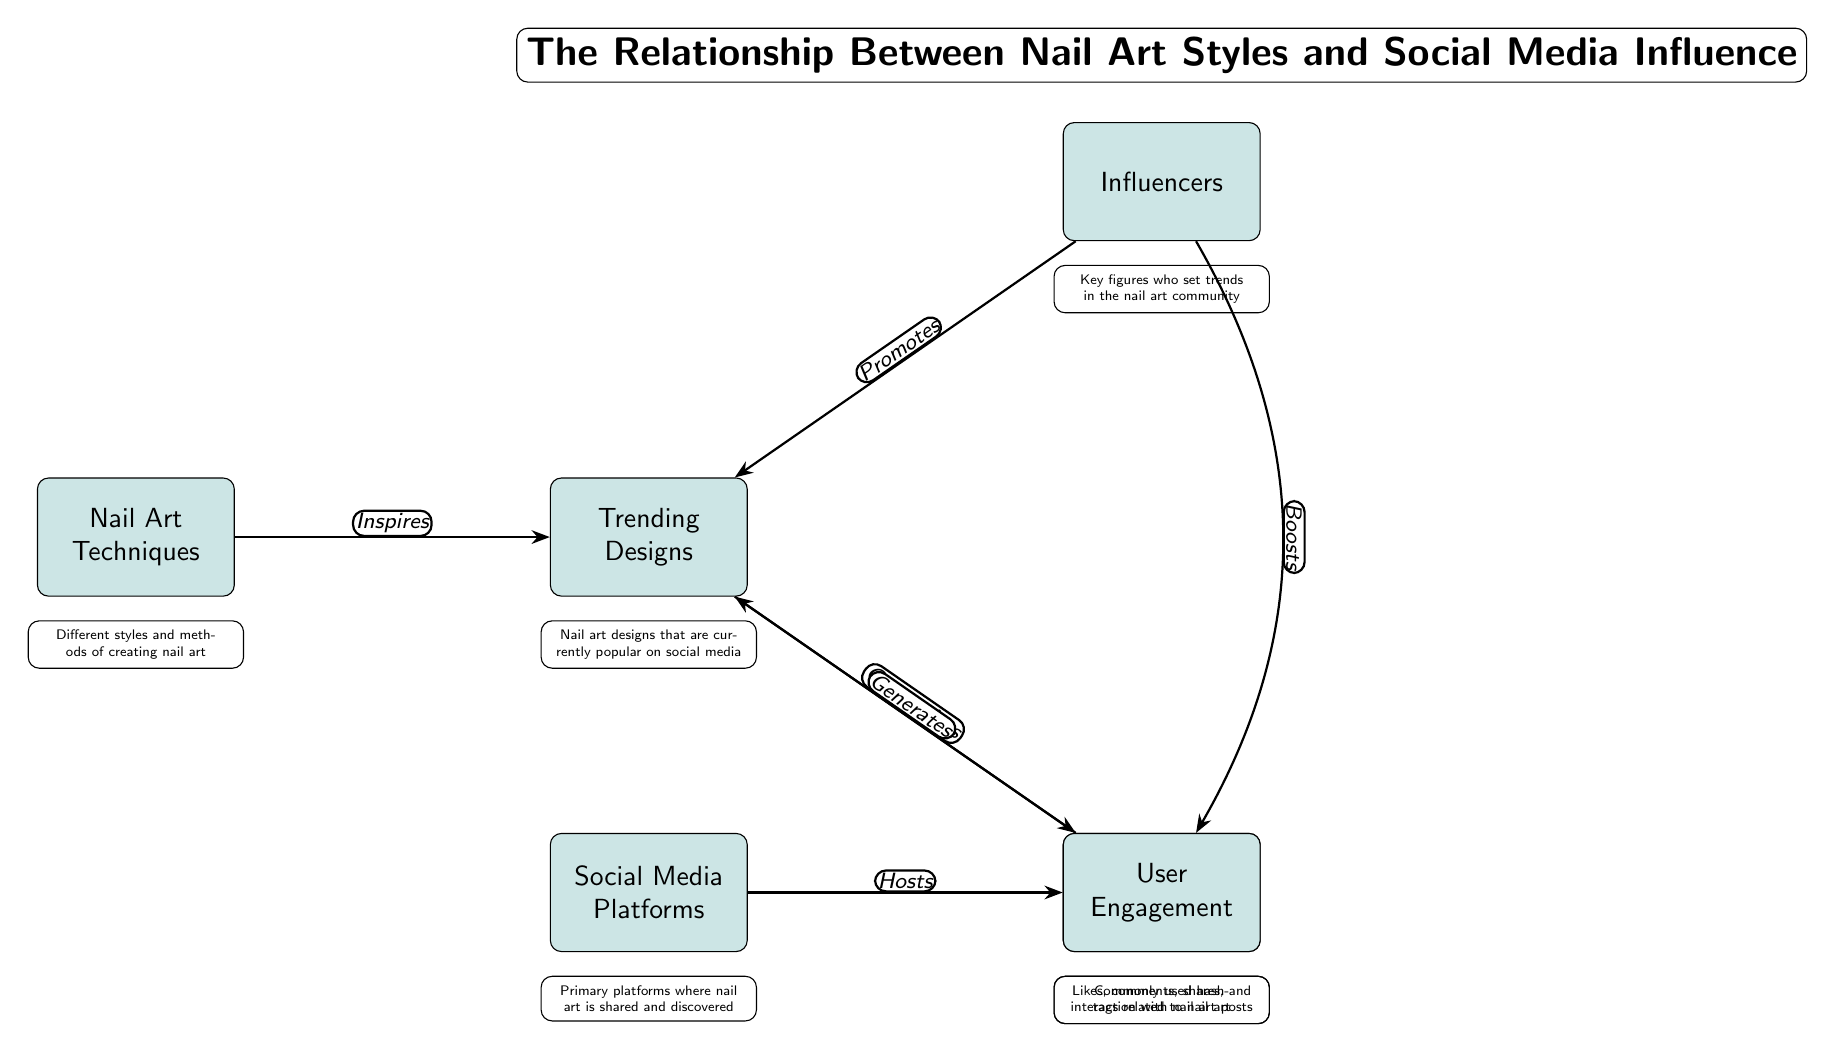What are the nodes represented in the diagram? The diagram consists of six main nodes: Nail Art Techniques, Trending Designs, Social Media Platforms, Popular Hashtags, Influencers, and User Engagement.
Answer: Six What type of relationship does "Social Media Platforms" have with "Popular Hashtags"? The relationship is labeled as "Hosts," indicating that social media platforms are the venues where popular hashtags are found.
Answer: Hosts How many edges are connecting different nodes in the diagram? There are a total of six edges connecting the nodes, which indicate the various relationships between the elements.
Answer: Six Which node directly influences the "Trending Designs"? The "Influencers" node directly influences "Trending Designs," suggesting that influential figures promote particular nail art designs.
Answer: Influencers What does "User Engagement" result from? User engagement results from the trending designs, indicating that they generate likes, comments, shares, etc. This shows the impact of designs on interaction levels.
Answer: Trending Designs How does "Nail Art Techniques" affect "Trending Designs"? Nail Art Techniques inspires Trending Designs, suggesting that the various techniques available lead to the development of new and popular design ideas.
Answer: Inspires Which node is categorized by "Popular Hashtags"? The node that is categorized by Popular Hashtags is "Trending Designs," implying that popular tags help in organizing and identifying current nail art designs.
Answer: Trending Designs What does the "Influencers" node do in relation to "User Engagement"? The "Influencers" node boosts User Engagement, indicating that the actions of influencers lead to increased interaction on posts about nail art.
Answer: Boosts 